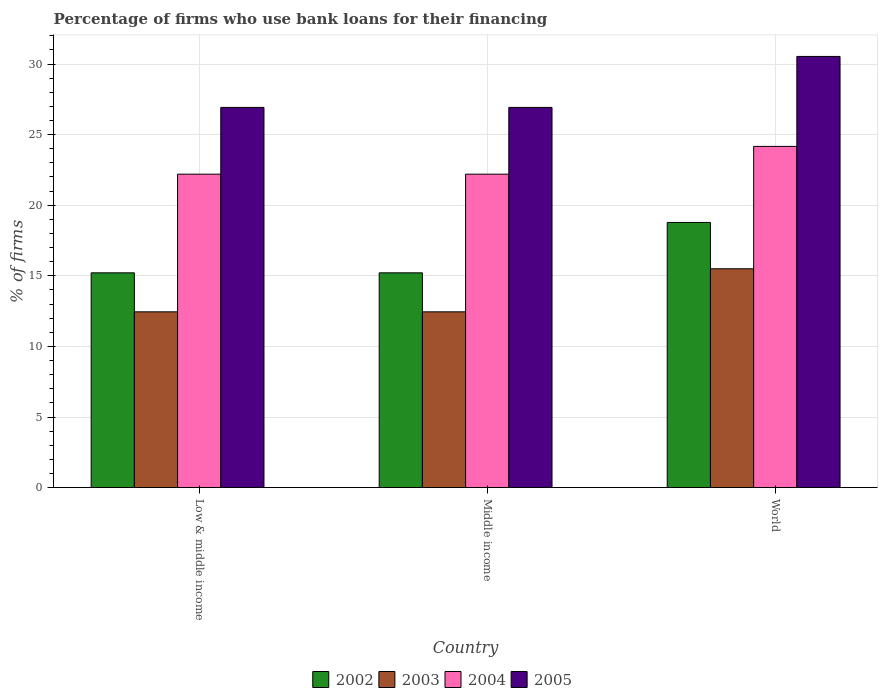How many groups of bars are there?
Offer a very short reply. 3. How many bars are there on the 1st tick from the left?
Your answer should be very brief. 4. How many bars are there on the 2nd tick from the right?
Provide a succinct answer. 4. What is the label of the 1st group of bars from the left?
Offer a very short reply. Low & middle income. Across all countries, what is the maximum percentage of firms who use bank loans for their financing in 2005?
Offer a very short reply. 30.54. Across all countries, what is the minimum percentage of firms who use bank loans for their financing in 2003?
Keep it short and to the point. 12.45. In which country was the percentage of firms who use bank loans for their financing in 2005 minimum?
Provide a succinct answer. Low & middle income. What is the total percentage of firms who use bank loans for their financing in 2005 in the graph?
Give a very brief answer. 84.39. What is the difference between the percentage of firms who use bank loans for their financing in 2003 in Low & middle income and that in World?
Offer a very short reply. -3.05. What is the difference between the percentage of firms who use bank loans for their financing in 2004 in Low & middle income and the percentage of firms who use bank loans for their financing in 2005 in Middle income?
Give a very brief answer. -4.73. What is the average percentage of firms who use bank loans for their financing in 2005 per country?
Provide a short and direct response. 28.13. What is the difference between the percentage of firms who use bank loans for their financing of/in 2004 and percentage of firms who use bank loans for their financing of/in 2005 in Middle income?
Offer a very short reply. -4.73. In how many countries, is the percentage of firms who use bank loans for their financing in 2002 greater than 30 %?
Your answer should be very brief. 0. What is the ratio of the percentage of firms who use bank loans for their financing in 2005 in Middle income to that in World?
Ensure brevity in your answer.  0.88. Is the difference between the percentage of firms who use bank loans for their financing in 2004 in Low & middle income and World greater than the difference between the percentage of firms who use bank loans for their financing in 2005 in Low & middle income and World?
Provide a succinct answer. Yes. What is the difference between the highest and the second highest percentage of firms who use bank loans for their financing in 2002?
Offer a terse response. 3.57. What is the difference between the highest and the lowest percentage of firms who use bank loans for their financing in 2004?
Your response must be concise. 1.97. Is the sum of the percentage of firms who use bank loans for their financing in 2002 in Low & middle income and World greater than the maximum percentage of firms who use bank loans for their financing in 2004 across all countries?
Your answer should be compact. Yes. Is it the case that in every country, the sum of the percentage of firms who use bank loans for their financing in 2004 and percentage of firms who use bank loans for their financing in 2003 is greater than the sum of percentage of firms who use bank loans for their financing in 2002 and percentage of firms who use bank loans for their financing in 2005?
Provide a short and direct response. No. What does the 2nd bar from the left in Low & middle income represents?
Give a very brief answer. 2003. What does the 3rd bar from the right in Middle income represents?
Your response must be concise. 2003. How many bars are there?
Offer a terse response. 12. What is the difference between two consecutive major ticks on the Y-axis?
Ensure brevity in your answer.  5. Are the values on the major ticks of Y-axis written in scientific E-notation?
Keep it short and to the point. No. Does the graph contain any zero values?
Your answer should be very brief. No. How are the legend labels stacked?
Ensure brevity in your answer.  Horizontal. What is the title of the graph?
Provide a succinct answer. Percentage of firms who use bank loans for their financing. What is the label or title of the X-axis?
Keep it short and to the point. Country. What is the label or title of the Y-axis?
Provide a short and direct response. % of firms. What is the % of firms in 2002 in Low & middle income?
Your answer should be very brief. 15.21. What is the % of firms in 2003 in Low & middle income?
Your answer should be very brief. 12.45. What is the % of firms of 2005 in Low & middle income?
Ensure brevity in your answer.  26.93. What is the % of firms of 2002 in Middle income?
Your answer should be compact. 15.21. What is the % of firms in 2003 in Middle income?
Offer a very short reply. 12.45. What is the % of firms of 2005 in Middle income?
Provide a short and direct response. 26.93. What is the % of firms of 2002 in World?
Offer a terse response. 18.78. What is the % of firms in 2004 in World?
Your answer should be very brief. 24.17. What is the % of firms in 2005 in World?
Your answer should be compact. 30.54. Across all countries, what is the maximum % of firms of 2002?
Offer a terse response. 18.78. Across all countries, what is the maximum % of firms of 2004?
Your answer should be compact. 24.17. Across all countries, what is the maximum % of firms of 2005?
Make the answer very short. 30.54. Across all countries, what is the minimum % of firms of 2002?
Provide a short and direct response. 15.21. Across all countries, what is the minimum % of firms of 2003?
Ensure brevity in your answer.  12.45. Across all countries, what is the minimum % of firms of 2004?
Offer a terse response. 22.2. Across all countries, what is the minimum % of firms of 2005?
Your response must be concise. 26.93. What is the total % of firms of 2002 in the graph?
Offer a very short reply. 49.21. What is the total % of firms in 2003 in the graph?
Offer a very short reply. 40.4. What is the total % of firms in 2004 in the graph?
Your response must be concise. 68.57. What is the total % of firms in 2005 in the graph?
Offer a terse response. 84.39. What is the difference between the % of firms in 2003 in Low & middle income and that in Middle income?
Provide a short and direct response. 0. What is the difference between the % of firms in 2004 in Low & middle income and that in Middle income?
Offer a terse response. 0. What is the difference between the % of firms in 2002 in Low & middle income and that in World?
Offer a terse response. -3.57. What is the difference between the % of firms in 2003 in Low & middle income and that in World?
Offer a very short reply. -3.05. What is the difference between the % of firms in 2004 in Low & middle income and that in World?
Provide a succinct answer. -1.97. What is the difference between the % of firms in 2005 in Low & middle income and that in World?
Provide a succinct answer. -3.61. What is the difference between the % of firms of 2002 in Middle income and that in World?
Your answer should be compact. -3.57. What is the difference between the % of firms in 2003 in Middle income and that in World?
Keep it short and to the point. -3.05. What is the difference between the % of firms of 2004 in Middle income and that in World?
Offer a very short reply. -1.97. What is the difference between the % of firms of 2005 in Middle income and that in World?
Give a very brief answer. -3.61. What is the difference between the % of firms in 2002 in Low & middle income and the % of firms in 2003 in Middle income?
Provide a succinct answer. 2.76. What is the difference between the % of firms of 2002 in Low & middle income and the % of firms of 2004 in Middle income?
Ensure brevity in your answer.  -6.99. What is the difference between the % of firms of 2002 in Low & middle income and the % of firms of 2005 in Middle income?
Make the answer very short. -11.72. What is the difference between the % of firms of 2003 in Low & middle income and the % of firms of 2004 in Middle income?
Provide a short and direct response. -9.75. What is the difference between the % of firms in 2003 in Low & middle income and the % of firms in 2005 in Middle income?
Make the answer very short. -14.48. What is the difference between the % of firms of 2004 in Low & middle income and the % of firms of 2005 in Middle income?
Your response must be concise. -4.73. What is the difference between the % of firms in 2002 in Low & middle income and the % of firms in 2003 in World?
Give a very brief answer. -0.29. What is the difference between the % of firms of 2002 in Low & middle income and the % of firms of 2004 in World?
Keep it short and to the point. -8.95. What is the difference between the % of firms in 2002 in Low & middle income and the % of firms in 2005 in World?
Ensure brevity in your answer.  -15.33. What is the difference between the % of firms in 2003 in Low & middle income and the % of firms in 2004 in World?
Provide a succinct answer. -11.72. What is the difference between the % of firms of 2003 in Low & middle income and the % of firms of 2005 in World?
Make the answer very short. -18.09. What is the difference between the % of firms of 2004 in Low & middle income and the % of firms of 2005 in World?
Offer a terse response. -8.34. What is the difference between the % of firms of 2002 in Middle income and the % of firms of 2003 in World?
Provide a short and direct response. -0.29. What is the difference between the % of firms of 2002 in Middle income and the % of firms of 2004 in World?
Provide a short and direct response. -8.95. What is the difference between the % of firms of 2002 in Middle income and the % of firms of 2005 in World?
Give a very brief answer. -15.33. What is the difference between the % of firms in 2003 in Middle income and the % of firms in 2004 in World?
Your response must be concise. -11.72. What is the difference between the % of firms in 2003 in Middle income and the % of firms in 2005 in World?
Offer a very short reply. -18.09. What is the difference between the % of firms in 2004 in Middle income and the % of firms in 2005 in World?
Your answer should be compact. -8.34. What is the average % of firms of 2002 per country?
Ensure brevity in your answer.  16.4. What is the average % of firms of 2003 per country?
Keep it short and to the point. 13.47. What is the average % of firms in 2004 per country?
Your response must be concise. 22.86. What is the average % of firms of 2005 per country?
Keep it short and to the point. 28.13. What is the difference between the % of firms in 2002 and % of firms in 2003 in Low & middle income?
Ensure brevity in your answer.  2.76. What is the difference between the % of firms in 2002 and % of firms in 2004 in Low & middle income?
Provide a succinct answer. -6.99. What is the difference between the % of firms of 2002 and % of firms of 2005 in Low & middle income?
Make the answer very short. -11.72. What is the difference between the % of firms of 2003 and % of firms of 2004 in Low & middle income?
Offer a very short reply. -9.75. What is the difference between the % of firms of 2003 and % of firms of 2005 in Low & middle income?
Give a very brief answer. -14.48. What is the difference between the % of firms in 2004 and % of firms in 2005 in Low & middle income?
Offer a very short reply. -4.73. What is the difference between the % of firms in 2002 and % of firms in 2003 in Middle income?
Your response must be concise. 2.76. What is the difference between the % of firms in 2002 and % of firms in 2004 in Middle income?
Provide a succinct answer. -6.99. What is the difference between the % of firms of 2002 and % of firms of 2005 in Middle income?
Provide a succinct answer. -11.72. What is the difference between the % of firms of 2003 and % of firms of 2004 in Middle income?
Your answer should be compact. -9.75. What is the difference between the % of firms of 2003 and % of firms of 2005 in Middle income?
Your answer should be compact. -14.48. What is the difference between the % of firms in 2004 and % of firms in 2005 in Middle income?
Offer a terse response. -4.73. What is the difference between the % of firms in 2002 and % of firms in 2003 in World?
Keep it short and to the point. 3.28. What is the difference between the % of firms in 2002 and % of firms in 2004 in World?
Provide a short and direct response. -5.39. What is the difference between the % of firms in 2002 and % of firms in 2005 in World?
Ensure brevity in your answer.  -11.76. What is the difference between the % of firms in 2003 and % of firms in 2004 in World?
Provide a succinct answer. -8.67. What is the difference between the % of firms of 2003 and % of firms of 2005 in World?
Your answer should be very brief. -15.04. What is the difference between the % of firms in 2004 and % of firms in 2005 in World?
Offer a terse response. -6.37. What is the ratio of the % of firms of 2002 in Low & middle income to that in Middle income?
Give a very brief answer. 1. What is the ratio of the % of firms of 2004 in Low & middle income to that in Middle income?
Provide a short and direct response. 1. What is the ratio of the % of firms in 2005 in Low & middle income to that in Middle income?
Your answer should be very brief. 1. What is the ratio of the % of firms in 2002 in Low & middle income to that in World?
Your answer should be compact. 0.81. What is the ratio of the % of firms in 2003 in Low & middle income to that in World?
Provide a short and direct response. 0.8. What is the ratio of the % of firms in 2004 in Low & middle income to that in World?
Give a very brief answer. 0.92. What is the ratio of the % of firms in 2005 in Low & middle income to that in World?
Make the answer very short. 0.88. What is the ratio of the % of firms in 2002 in Middle income to that in World?
Ensure brevity in your answer.  0.81. What is the ratio of the % of firms in 2003 in Middle income to that in World?
Provide a short and direct response. 0.8. What is the ratio of the % of firms of 2004 in Middle income to that in World?
Keep it short and to the point. 0.92. What is the ratio of the % of firms in 2005 in Middle income to that in World?
Your answer should be very brief. 0.88. What is the difference between the highest and the second highest % of firms in 2002?
Your answer should be compact. 3.57. What is the difference between the highest and the second highest % of firms of 2003?
Provide a succinct answer. 3.05. What is the difference between the highest and the second highest % of firms of 2004?
Ensure brevity in your answer.  1.97. What is the difference between the highest and the second highest % of firms of 2005?
Give a very brief answer. 3.61. What is the difference between the highest and the lowest % of firms in 2002?
Ensure brevity in your answer.  3.57. What is the difference between the highest and the lowest % of firms of 2003?
Ensure brevity in your answer.  3.05. What is the difference between the highest and the lowest % of firms of 2004?
Your answer should be very brief. 1.97. What is the difference between the highest and the lowest % of firms in 2005?
Provide a short and direct response. 3.61. 